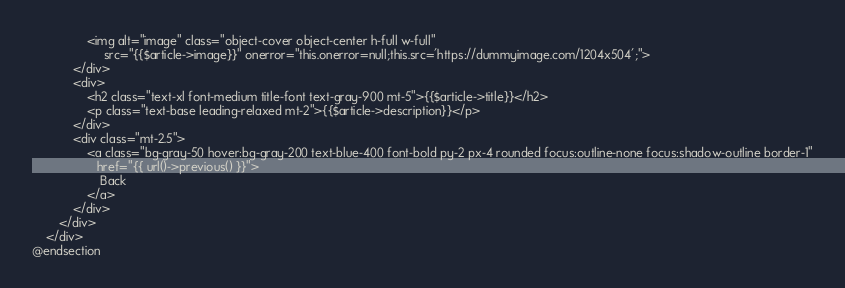Convert code to text. <code><loc_0><loc_0><loc_500><loc_500><_PHP_>                <img alt="image" class="object-cover object-center h-full w-full"
                     src="{{$article->image}}" onerror="this.onerror=null;this.src='https://dummyimage.com/1204x504';">
            </div>
            <div>
                <h2 class="text-xl font-medium title-font text-gray-900 mt-5">{{$article->title}}</h2>
                <p class="text-base leading-relaxed mt-2">{{$article->description}}</p>
            </div>
            <div class="mt-2.5">
                <a class="bg-gray-50 hover:bg-gray-200 text-blue-400 font-bold py-2 px-4 rounded focus:outline-none focus:shadow-outline border-1"
                   href="{{ url()->previous() }}">
                    Back
                </a>
            </div>
        </div>
    </div>
@endsection
</code> 